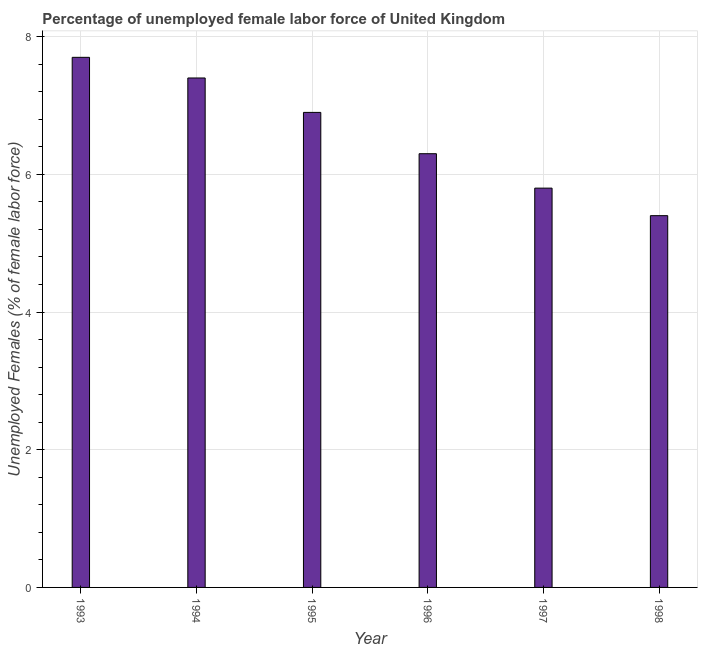Does the graph contain any zero values?
Offer a terse response. No. What is the title of the graph?
Keep it short and to the point. Percentage of unemployed female labor force of United Kingdom. What is the label or title of the X-axis?
Your answer should be compact. Year. What is the label or title of the Y-axis?
Offer a very short reply. Unemployed Females (% of female labor force). What is the total unemployed female labour force in 1993?
Offer a terse response. 7.7. Across all years, what is the maximum total unemployed female labour force?
Your answer should be very brief. 7.7. Across all years, what is the minimum total unemployed female labour force?
Your answer should be very brief. 5.4. What is the sum of the total unemployed female labour force?
Provide a short and direct response. 39.5. What is the average total unemployed female labour force per year?
Make the answer very short. 6.58. What is the median total unemployed female labour force?
Your answer should be very brief. 6.6. In how many years, is the total unemployed female labour force greater than 0.4 %?
Ensure brevity in your answer.  6. Do a majority of the years between 1998 and 1994 (inclusive) have total unemployed female labour force greater than 4.4 %?
Provide a succinct answer. Yes. What is the ratio of the total unemployed female labour force in 1993 to that in 1997?
Your answer should be compact. 1.33. Is the total unemployed female labour force in 1994 less than that in 1997?
Your answer should be compact. No. Is the difference between the total unemployed female labour force in 1995 and 1996 greater than the difference between any two years?
Ensure brevity in your answer.  No. Is the sum of the total unemployed female labour force in 1997 and 1998 greater than the maximum total unemployed female labour force across all years?
Ensure brevity in your answer.  Yes. What is the difference between the highest and the lowest total unemployed female labour force?
Offer a terse response. 2.3. In how many years, is the total unemployed female labour force greater than the average total unemployed female labour force taken over all years?
Offer a very short reply. 3. How many bars are there?
Offer a terse response. 6. Are all the bars in the graph horizontal?
Provide a short and direct response. No. What is the difference between two consecutive major ticks on the Y-axis?
Offer a very short reply. 2. What is the Unemployed Females (% of female labor force) in 1993?
Your answer should be very brief. 7.7. What is the Unemployed Females (% of female labor force) of 1994?
Make the answer very short. 7.4. What is the Unemployed Females (% of female labor force) in 1995?
Provide a succinct answer. 6.9. What is the Unemployed Females (% of female labor force) in 1996?
Your answer should be very brief. 6.3. What is the Unemployed Females (% of female labor force) in 1997?
Provide a succinct answer. 5.8. What is the Unemployed Females (% of female labor force) in 1998?
Give a very brief answer. 5.4. What is the difference between the Unemployed Females (% of female labor force) in 1993 and 1994?
Ensure brevity in your answer.  0.3. What is the difference between the Unemployed Females (% of female labor force) in 1993 and 1995?
Your response must be concise. 0.8. What is the difference between the Unemployed Females (% of female labor force) in 1994 and 1997?
Keep it short and to the point. 1.6. What is the difference between the Unemployed Females (% of female labor force) in 1994 and 1998?
Your answer should be compact. 2. What is the difference between the Unemployed Females (% of female labor force) in 1995 and 1996?
Provide a succinct answer. 0.6. What is the difference between the Unemployed Females (% of female labor force) in 1995 and 1997?
Your response must be concise. 1.1. What is the difference between the Unemployed Females (% of female labor force) in 1996 and 1998?
Ensure brevity in your answer.  0.9. What is the ratio of the Unemployed Females (% of female labor force) in 1993 to that in 1994?
Ensure brevity in your answer.  1.04. What is the ratio of the Unemployed Females (% of female labor force) in 1993 to that in 1995?
Your answer should be compact. 1.12. What is the ratio of the Unemployed Females (% of female labor force) in 1993 to that in 1996?
Your answer should be compact. 1.22. What is the ratio of the Unemployed Females (% of female labor force) in 1993 to that in 1997?
Provide a short and direct response. 1.33. What is the ratio of the Unemployed Females (% of female labor force) in 1993 to that in 1998?
Provide a short and direct response. 1.43. What is the ratio of the Unemployed Females (% of female labor force) in 1994 to that in 1995?
Keep it short and to the point. 1.07. What is the ratio of the Unemployed Females (% of female labor force) in 1994 to that in 1996?
Your response must be concise. 1.18. What is the ratio of the Unemployed Females (% of female labor force) in 1994 to that in 1997?
Provide a short and direct response. 1.28. What is the ratio of the Unemployed Females (% of female labor force) in 1994 to that in 1998?
Provide a succinct answer. 1.37. What is the ratio of the Unemployed Females (% of female labor force) in 1995 to that in 1996?
Your answer should be very brief. 1.09. What is the ratio of the Unemployed Females (% of female labor force) in 1995 to that in 1997?
Make the answer very short. 1.19. What is the ratio of the Unemployed Females (% of female labor force) in 1995 to that in 1998?
Make the answer very short. 1.28. What is the ratio of the Unemployed Females (% of female labor force) in 1996 to that in 1997?
Offer a terse response. 1.09. What is the ratio of the Unemployed Females (% of female labor force) in 1996 to that in 1998?
Your answer should be very brief. 1.17. What is the ratio of the Unemployed Females (% of female labor force) in 1997 to that in 1998?
Provide a succinct answer. 1.07. 